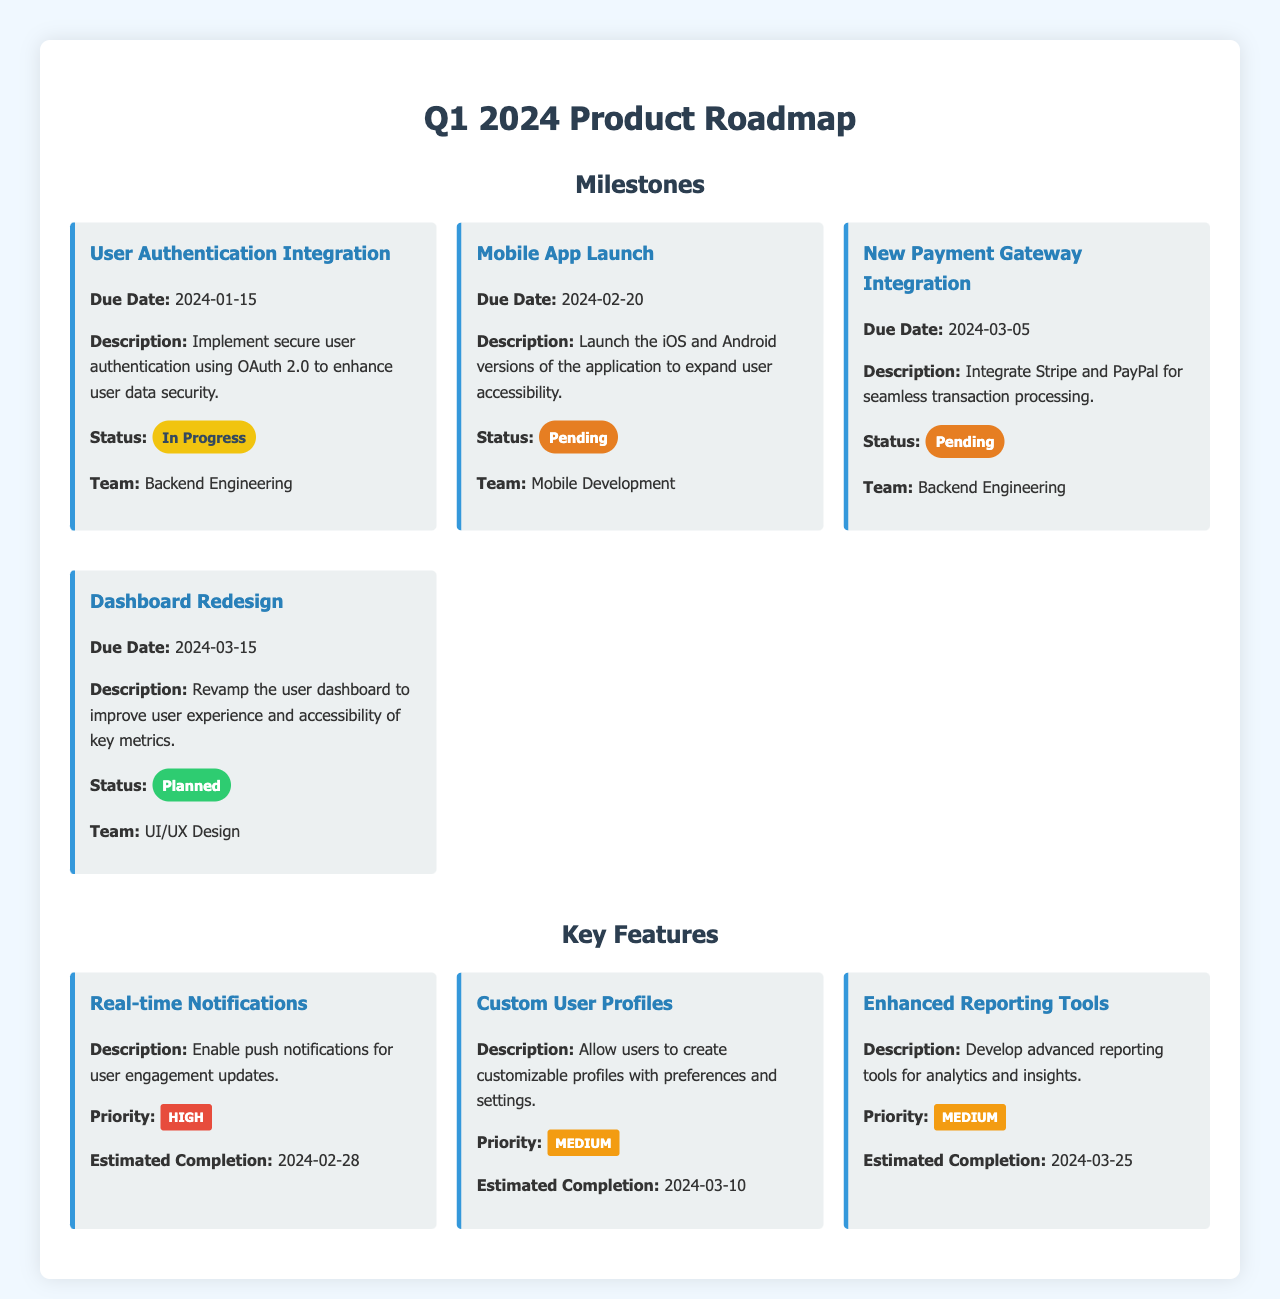What is the due date for User Authentication Integration? The due date for User Authentication Integration is mentioned directly in the document.
Answer: 2024-01-15 What is the status of the Dashboard Redesign? The status indicates whether the task is in progress, pending, or planned, which can be found in the document.
Answer: Planned Which team is responsible for the Mobile App Launch? The document specifies which team is assigned to each milestone, indicating responsibility.
Answer: Mobile Development What is the priority level of Real-time Notifications? The priority level is clearly indicated for each key feature within the document.
Answer: High When is the estimated completion date for Enhanced Reporting Tools? The estimated completion date is provided for each feature, helping to understand project timelines.
Answer: 2024-03-25 What feature allows users to create customizable profiles? This refers to a specific feature described in the document that enables user customization.
Answer: Custom User Profiles How many milestones are listed in the document? The document provides a count of the milestones featured, which can be directly observed.
Answer: Four What is the description of the New Payment Gateway Integration? The description provides information about what each milestone involves, summarizing its objectives.
Answer: Integrate Stripe and PayPal for seamless transaction processing Which feature has a medium priority and estimated completion on 2024-03-10? This question combines priority level and timing to identify specific features as noted in the document.
Answer: Custom User Profiles 